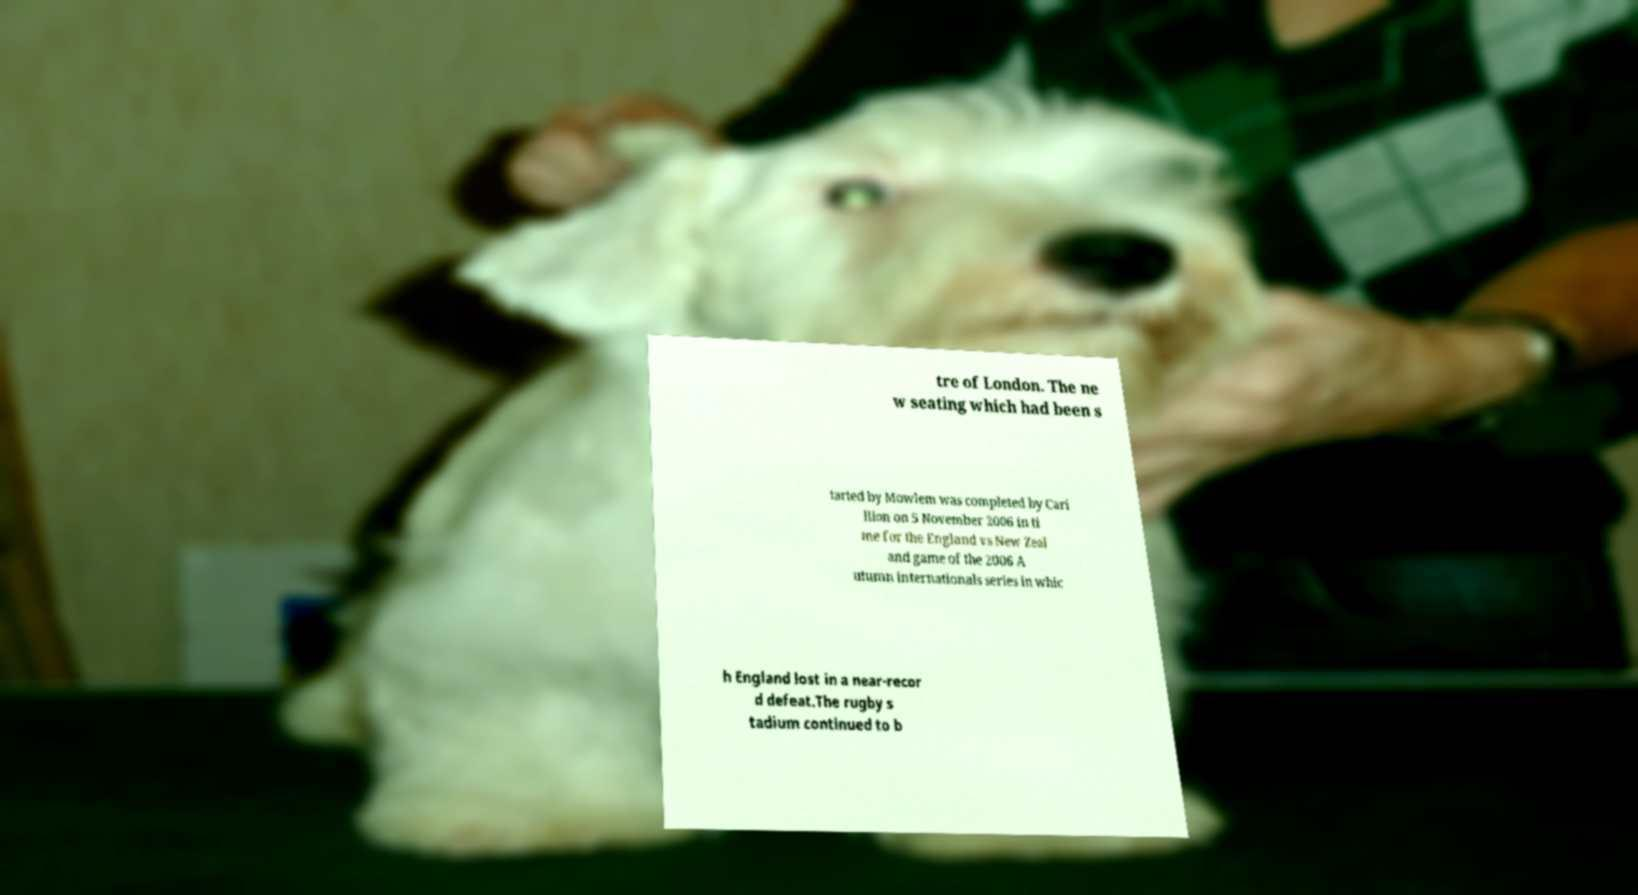Could you assist in decoding the text presented in this image and type it out clearly? tre of London. The ne w seating which had been s tarted by Mowlem was completed by Cari llion on 5 November 2006 in ti me for the England vs New Zeal and game of the 2006 A utumn internationals series in whic h England lost in a near-recor d defeat.The rugby s tadium continued to b 